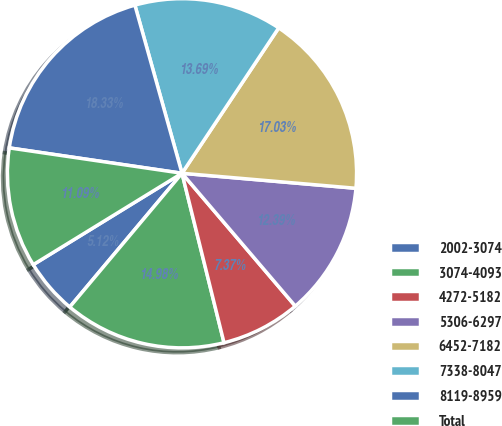Convert chart to OTSL. <chart><loc_0><loc_0><loc_500><loc_500><pie_chart><fcel>2002-3074<fcel>3074-4093<fcel>4272-5182<fcel>5306-6297<fcel>6452-7182<fcel>7338-8047<fcel>8119-8959<fcel>Total<nl><fcel>5.12%<fcel>14.98%<fcel>7.37%<fcel>12.39%<fcel>17.03%<fcel>13.69%<fcel>18.33%<fcel>11.09%<nl></chart> 